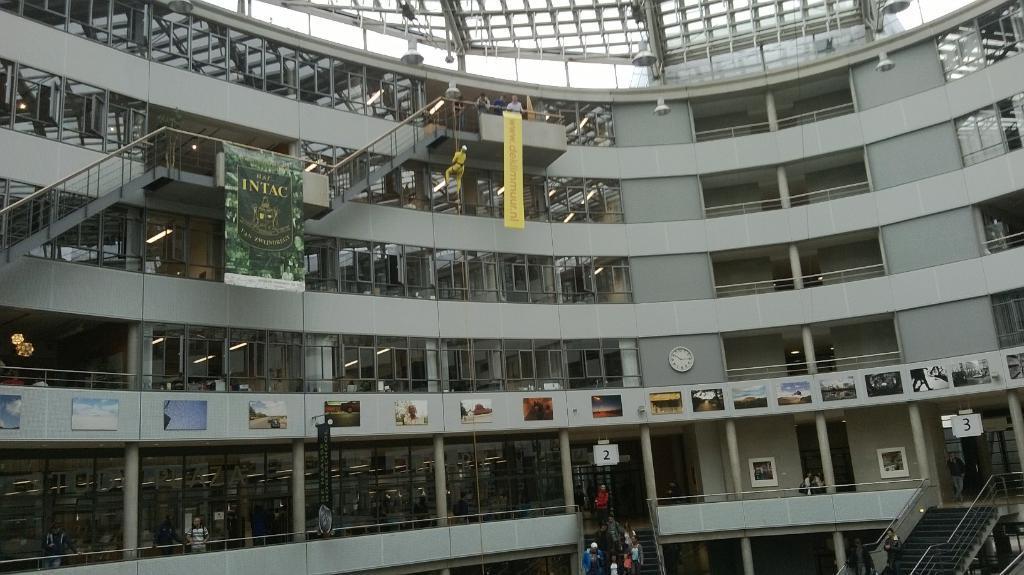Could you give a brief overview of what you see in this image? In this image I can see a building, staircases, boards, posters, metal rods, rooftop, wall clock, doors, lights and a crowd. This image is taken may be in a building. 